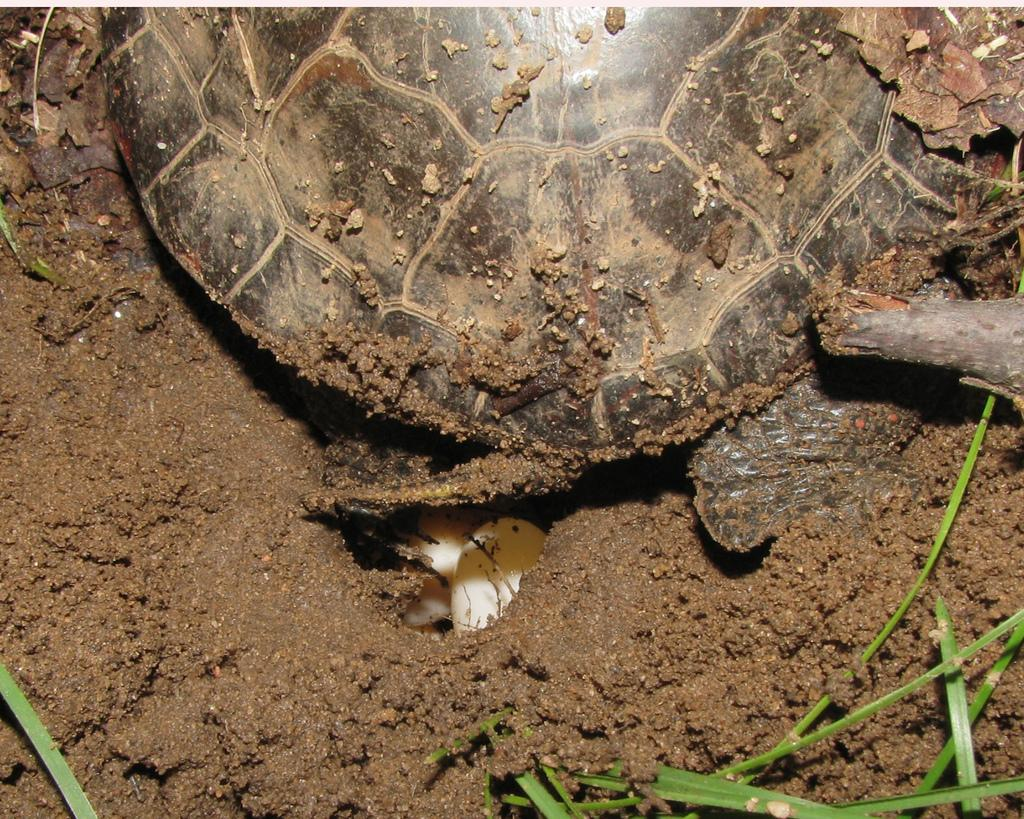What type of animal is present in the image? There is a turtle in the image. What type of vegetation can be seen in the image? There is grass in the image. What type of ground surface is visible in the image? There is soil in the image. What type of regret can be seen expressed by the turtle in the image? There is no indication of regret in the image; it simply features a turtle in a natural setting. 